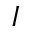Convert formula to latex. <formula><loc_0><loc_0><loc_500><loc_500>I</formula> 